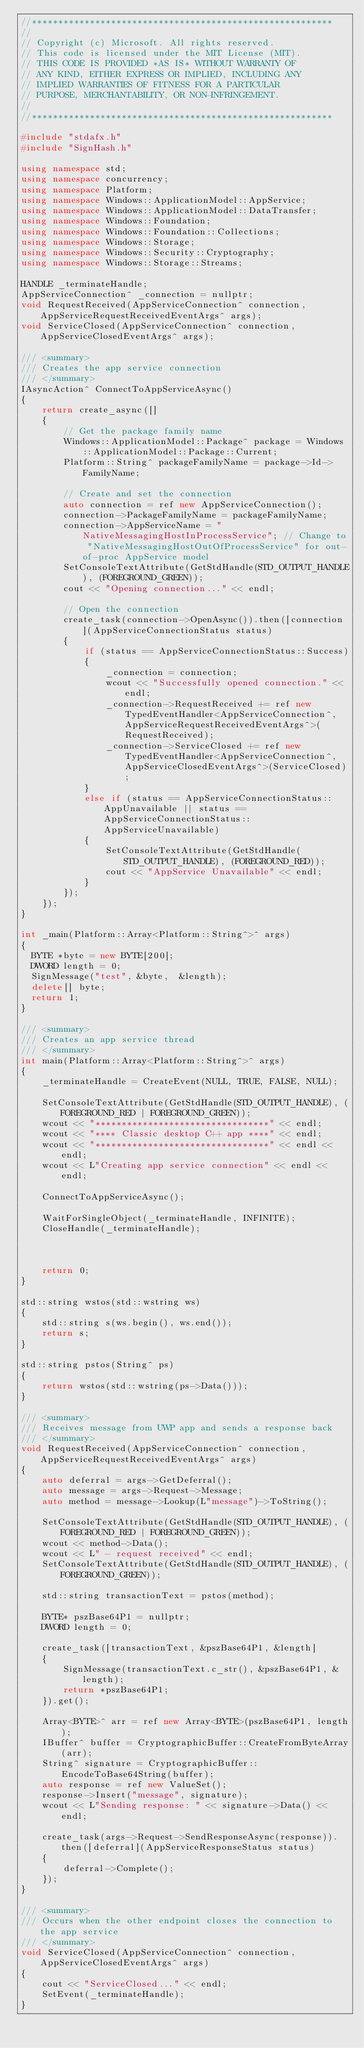Convert code to text. <code><loc_0><loc_0><loc_500><loc_500><_C++_>//*********************************************************
//
// Copyright (c) Microsoft. All rights reserved.
// This code is licensed under the MIT License (MIT).
// THIS CODE IS PROVIDED *AS IS* WITHOUT WARRANTY OF
// ANY KIND, EITHER EXPRESS OR IMPLIED, INCLUDING ANY
// IMPLIED WARRANTIES OF FITNESS FOR A PARTICULAR
// PURPOSE, MERCHANTABILITY, OR NON-INFRINGEMENT.
//
//*********************************************************

#include "stdafx.h"
#include "SignHash.h"

using namespace std;
using namespace concurrency;
using namespace Platform;
using namespace Windows::ApplicationModel::AppService;
using namespace Windows::ApplicationModel::DataTransfer;
using namespace Windows::Foundation;
using namespace Windows::Foundation::Collections;
using namespace Windows::Storage;
using namespace Windows::Security::Cryptography;
using namespace Windows::Storage::Streams;

HANDLE _terminateHandle;
AppServiceConnection^ _connection = nullptr;
void RequestReceived(AppServiceConnection^ connection, AppServiceRequestReceivedEventArgs^ args);
void ServiceClosed(AppServiceConnection^ connection, AppServiceClosedEventArgs^ args);

/// <summary>
/// Creates the app service connection
/// </summary>
IAsyncAction^ ConnectToAppServiceAsync()
{
    return create_async([]
    {
        // Get the package family name
        Windows::ApplicationModel::Package^ package = Windows::ApplicationModel::Package::Current;
        Platform::String^ packageFamilyName = package->Id->FamilyName;

        // Create and set the connection
        auto connection = ref new AppServiceConnection();
        connection->PackageFamilyName = packageFamilyName;
        connection->AppServiceName = "NativeMessagingHostInProcessService"; // Change to "NativeMessagingHostOutOfProcessService" for out-of-proc AppService model
        SetConsoleTextAttribute(GetStdHandle(STD_OUTPUT_HANDLE), (FOREGROUND_GREEN));
        cout << "Opening connection..." << endl;

        // Open the connection
        create_task(connection->OpenAsync()).then([connection](AppServiceConnectionStatus status)
        {
            if (status == AppServiceConnectionStatus::Success)
            {
                _connection = connection;
                wcout << "Successfully opened connection." << endl;
                _connection->RequestReceived += ref new TypedEventHandler<AppServiceConnection^, AppServiceRequestReceivedEventArgs^>(RequestReceived);
                _connection->ServiceClosed += ref new TypedEventHandler<AppServiceConnection^, AppServiceClosedEventArgs^>(ServiceClosed);
            }
            else if (status == AppServiceConnectionStatus::AppUnavailable || status == AppServiceConnectionStatus::AppServiceUnavailable)
            {
                SetConsoleTextAttribute(GetStdHandle(STD_OUTPUT_HANDLE), (FOREGROUND_RED));
                cout << "AppService Unavailable" << endl;
            }
        });
    });
}

int _main(Platform::Array<Platform::String^>^ args)
{
	BYTE *byte = new BYTE[200];
	DWORD length = 0;
	SignMessage("test", &byte,  &length);
	delete[] byte;
	return 1;
}

/// <summary>
/// Creates an app service thread
/// </summary>
int main(Platform::Array<Platform::String^>^ args)
{
    _terminateHandle = CreateEvent(NULL, TRUE, FALSE, NULL);

    SetConsoleTextAttribute(GetStdHandle(STD_OUTPUT_HANDLE), (FOREGROUND_RED | FOREGROUND_GREEN));
    wcout << "*********************************" << endl;
    wcout << "**** Classic desktop C++ app ****" << endl;
    wcout << "*********************************" << endl << endl;
    wcout << L"Creating app service connection" << endl << endl;

    ConnectToAppServiceAsync();

    WaitForSingleObject(_terminateHandle, INFINITE);
    CloseHandle(_terminateHandle);

	

    return 0;
}

std::string wstos(std::wstring ws)
{
    std::string s(ws.begin(), ws.end());
    return s;
}

std::string pstos(String^ ps)
{
    return wstos(std::wstring(ps->Data()));
}

/// <summary>
/// Receives message from UWP app and sends a response back
/// </summary>
void RequestReceived(AppServiceConnection^ connection, AppServiceRequestReceivedEventArgs^ args)
{
    auto deferral = args->GetDeferral();
    auto message = args->Request->Message;
    auto method = message->Lookup(L"message")->ToString();

    SetConsoleTextAttribute(GetStdHandle(STD_OUTPUT_HANDLE), (FOREGROUND_RED | FOREGROUND_GREEN));
    wcout << method->Data();
    wcout << L" - request received" << endl;
    SetConsoleTextAttribute(GetStdHandle(STD_OUTPUT_HANDLE), (FOREGROUND_GREEN));

    std::string transactionText = pstos(method);

    BYTE* pszBase64P1 = nullptr;
    DWORD length = 0;

    create_task([transactionText, &pszBase64P1, &length]
    {
        SignMessage(transactionText.c_str(), &pszBase64P1, &length);
        return *pszBase64P1;
    }).get();

    Array<BYTE>^ arr = ref new Array<BYTE>(pszBase64P1, length);
    IBuffer^ buffer = CryptographicBuffer::CreateFromByteArray(arr);
    String^ signature = CryptographicBuffer::EncodeToBase64String(buffer);
    auto response = ref new ValueSet();
    response->Insert("message", signature);
    wcout << L"Sending response: " << signature->Data() << endl;

    create_task(args->Request->SendResponseAsync(response)).then([deferral](AppServiceResponseStatus status)
    {
        deferral->Complete();
    });
}

/// <summary>
/// Occurs when the other endpoint closes the connection to the app service
/// </summary>
void ServiceClosed(AppServiceConnection^ connection, AppServiceClosedEventArgs^ args)
{
    cout << "ServiceClosed..." << endl;
    SetEvent(_terminateHandle);
}
</code> 